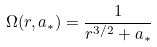Convert formula to latex. <formula><loc_0><loc_0><loc_500><loc_500>\Omega ( r , a _ { * } ) = \frac { 1 } { r ^ { 3 / 2 } + a _ { * } }</formula> 